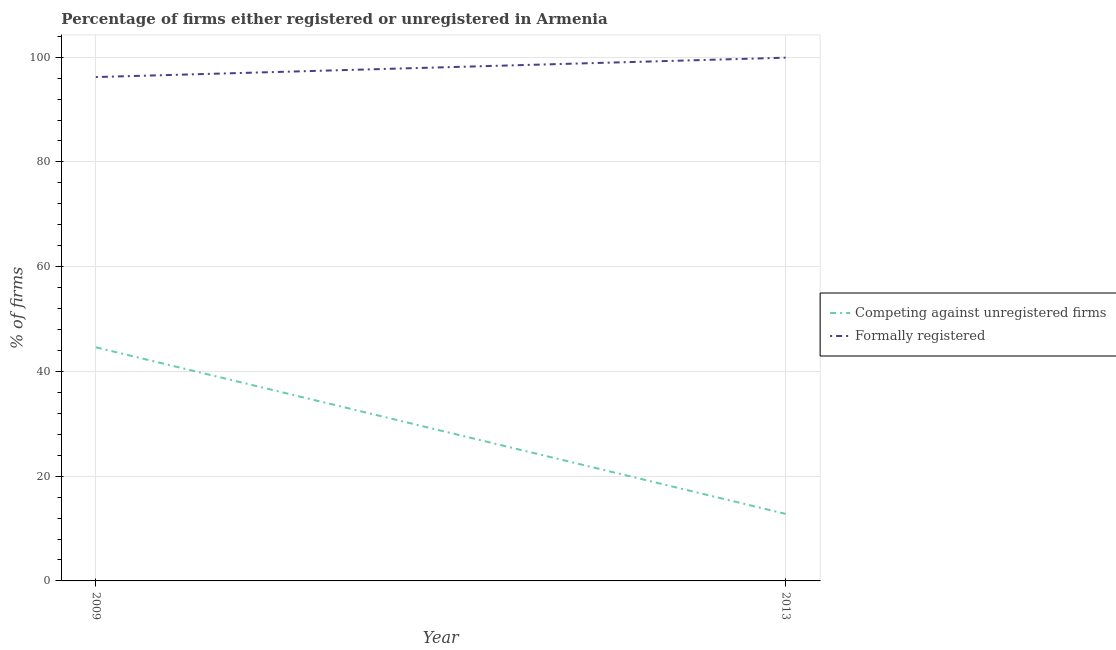Does the line corresponding to percentage of formally registered firms intersect with the line corresponding to percentage of registered firms?
Your response must be concise. No. Is the number of lines equal to the number of legend labels?
Provide a short and direct response. Yes. What is the percentage of formally registered firms in 2013?
Ensure brevity in your answer.  99.9. Across all years, what is the maximum percentage of registered firms?
Make the answer very short. 44.6. Across all years, what is the minimum percentage of registered firms?
Ensure brevity in your answer.  12.8. In which year was the percentage of registered firms maximum?
Offer a terse response. 2009. In which year was the percentage of formally registered firms minimum?
Make the answer very short. 2009. What is the total percentage of registered firms in the graph?
Keep it short and to the point. 57.4. What is the difference between the percentage of formally registered firms in 2009 and that in 2013?
Give a very brief answer. -3.7. What is the difference between the percentage of registered firms in 2009 and the percentage of formally registered firms in 2013?
Give a very brief answer. -55.3. What is the average percentage of formally registered firms per year?
Offer a terse response. 98.05. In the year 2013, what is the difference between the percentage of registered firms and percentage of formally registered firms?
Keep it short and to the point. -87.1. What is the ratio of the percentage of formally registered firms in 2009 to that in 2013?
Offer a terse response. 0.96. Is the percentage of formally registered firms in 2009 less than that in 2013?
Give a very brief answer. Yes. How many years are there in the graph?
Keep it short and to the point. 2. What is the difference between two consecutive major ticks on the Y-axis?
Your answer should be very brief. 20. Does the graph contain grids?
Your response must be concise. Yes. Where does the legend appear in the graph?
Give a very brief answer. Center right. How many legend labels are there?
Your answer should be very brief. 2. What is the title of the graph?
Your answer should be very brief. Percentage of firms either registered or unregistered in Armenia. What is the label or title of the X-axis?
Give a very brief answer. Year. What is the label or title of the Y-axis?
Give a very brief answer. % of firms. What is the % of firms of Competing against unregistered firms in 2009?
Your answer should be very brief. 44.6. What is the % of firms of Formally registered in 2009?
Make the answer very short. 96.2. What is the % of firms of Formally registered in 2013?
Offer a terse response. 99.9. Across all years, what is the maximum % of firms of Competing against unregistered firms?
Keep it short and to the point. 44.6. Across all years, what is the maximum % of firms in Formally registered?
Your response must be concise. 99.9. Across all years, what is the minimum % of firms of Competing against unregistered firms?
Your answer should be very brief. 12.8. Across all years, what is the minimum % of firms of Formally registered?
Keep it short and to the point. 96.2. What is the total % of firms of Competing against unregistered firms in the graph?
Offer a terse response. 57.4. What is the total % of firms in Formally registered in the graph?
Give a very brief answer. 196.1. What is the difference between the % of firms of Competing against unregistered firms in 2009 and that in 2013?
Provide a succinct answer. 31.8. What is the difference between the % of firms in Formally registered in 2009 and that in 2013?
Give a very brief answer. -3.7. What is the difference between the % of firms of Competing against unregistered firms in 2009 and the % of firms of Formally registered in 2013?
Keep it short and to the point. -55.3. What is the average % of firms of Competing against unregistered firms per year?
Give a very brief answer. 28.7. What is the average % of firms in Formally registered per year?
Keep it short and to the point. 98.05. In the year 2009, what is the difference between the % of firms in Competing against unregistered firms and % of firms in Formally registered?
Provide a short and direct response. -51.6. In the year 2013, what is the difference between the % of firms in Competing against unregistered firms and % of firms in Formally registered?
Offer a terse response. -87.1. What is the ratio of the % of firms in Competing against unregistered firms in 2009 to that in 2013?
Your answer should be very brief. 3.48. What is the difference between the highest and the second highest % of firms in Competing against unregistered firms?
Give a very brief answer. 31.8. What is the difference between the highest and the lowest % of firms in Competing against unregistered firms?
Make the answer very short. 31.8. What is the difference between the highest and the lowest % of firms in Formally registered?
Your answer should be compact. 3.7. 